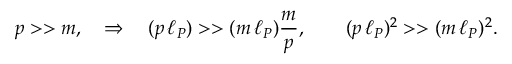<formula> <loc_0><loc_0><loc_500><loc_500>p > > m , \quad \Rightarrow \quad ( p \, \ell _ { P } ) > > ( m \, \ell _ { P } ) \frac { m } { p } , \quad ( p \, \ell _ { P } ) ^ { 2 } > > ( m \, \ell _ { P } ) ^ { 2 } .</formula> 